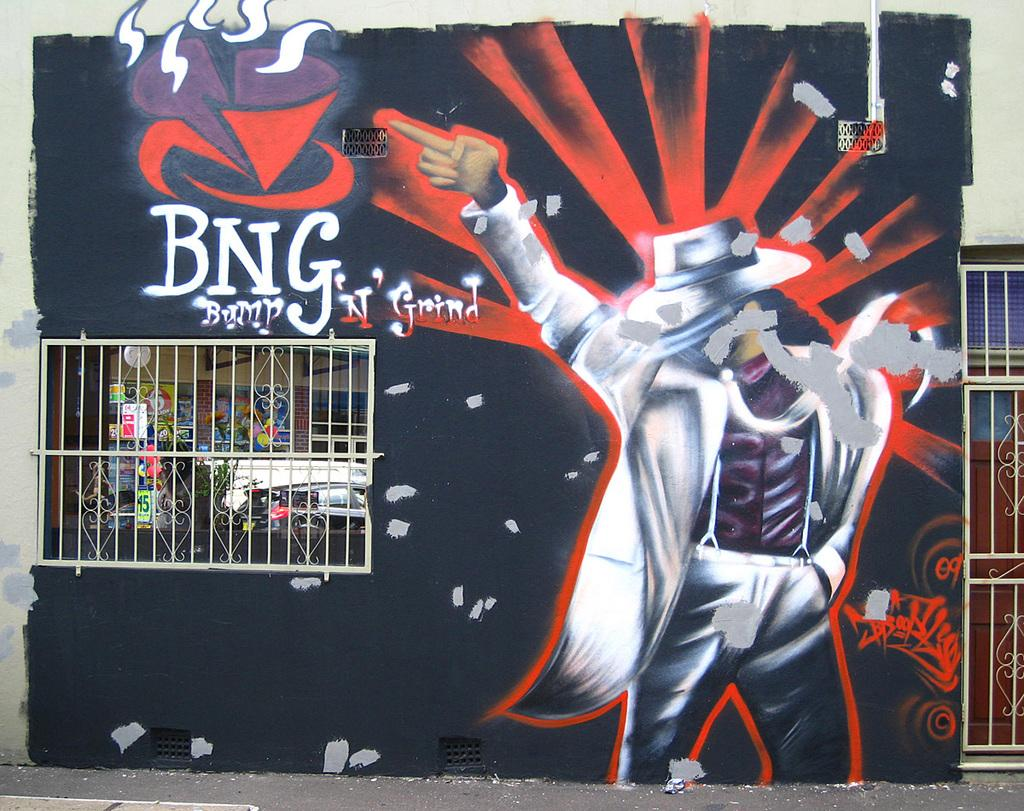Provide a one-sentence caption for the provided image. A mural of a man who looks like Michael Jackson contains the writing "BNG Bump N' Grind". 